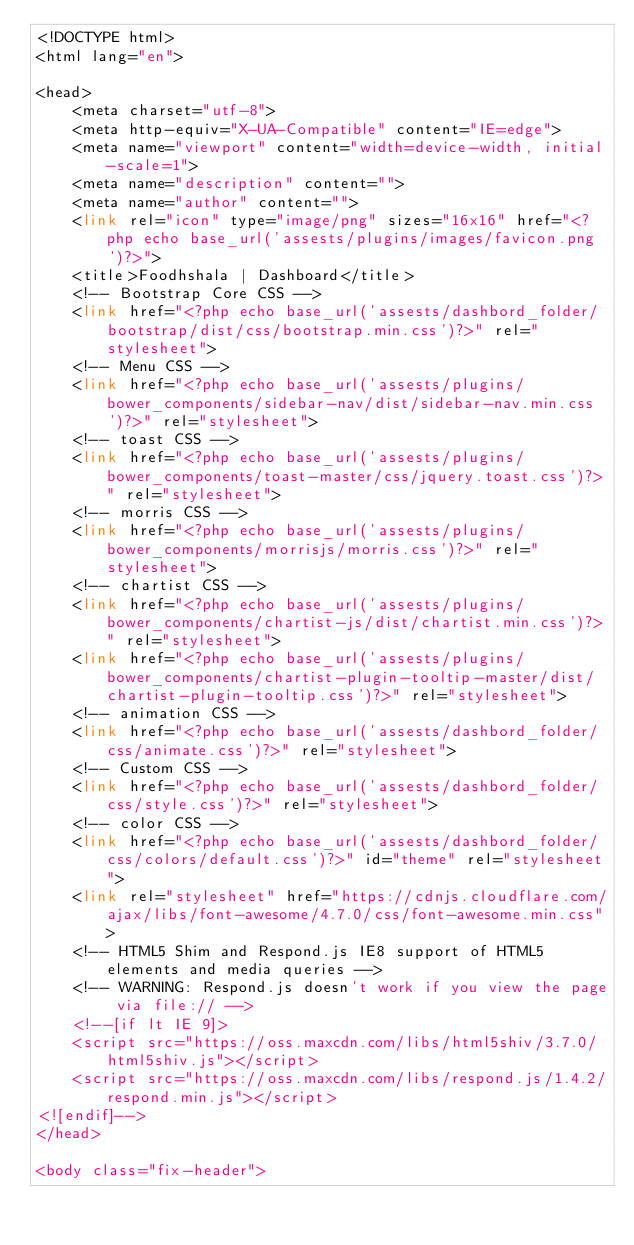Convert code to text. <code><loc_0><loc_0><loc_500><loc_500><_PHP_><!DOCTYPE html>
<html lang="en">

<head>
    <meta charset="utf-8">
    <meta http-equiv="X-UA-Compatible" content="IE=edge">
    <meta name="viewport" content="width=device-width, initial-scale=1">
    <meta name="description" content="">
    <meta name="author" content="">
    <link rel="icon" type="image/png" sizes="16x16" href="<?php echo base_url('assests/plugins/images/favicon.png')?>">
    <title>Foodhshala | Dashboard</title>
    <!-- Bootstrap Core CSS -->
    <link href="<?php echo base_url('assests/dashbord_folder/bootstrap/dist/css/bootstrap.min.css')?>" rel="stylesheet">
    <!-- Menu CSS -->
    <link href="<?php echo base_url('assests/plugins/bower_components/sidebar-nav/dist/sidebar-nav.min.css')?>" rel="stylesheet">
    <!-- toast CSS -->
    <link href="<?php echo base_url('assests/plugins/bower_components/toast-master/css/jquery.toast.css')?>" rel="stylesheet">
    <!-- morris CSS -->
    <link href="<?php echo base_url('assests/plugins/bower_components/morrisjs/morris.css')?>" rel="stylesheet">
    <!-- chartist CSS -->
    <link href="<?php echo base_url('assests/plugins/bower_components/chartist-js/dist/chartist.min.css')?>" rel="stylesheet">
    <link href="<?php echo base_url('assests/plugins/bower_components/chartist-plugin-tooltip-master/dist/chartist-plugin-tooltip.css')?>" rel="stylesheet">
    <!-- animation CSS -->
    <link href="<?php echo base_url('assests/dashbord_folder/css/animate.css')?>" rel="stylesheet">
    <!-- Custom CSS -->
    <link href="<?php echo base_url('assests/dashbord_folder/css/style.css')?>" rel="stylesheet">
    <!-- color CSS -->
    <link href="<?php echo base_url('assests/dashbord_folder/css/colors/default.css')?>" id="theme" rel="stylesheet">
    <link rel="stylesheet" href="https://cdnjs.cloudflare.com/ajax/libs/font-awesome/4.7.0/css/font-awesome.min.css">
    <!-- HTML5 Shim and Respond.js IE8 support of HTML5 elements and media queries -->
    <!-- WARNING: Respond.js doesn't work if you view the page via file:// -->
    <!--[if lt IE 9]>
    <script src="https://oss.maxcdn.com/libs/html5shiv/3.7.0/html5shiv.js"></script>
    <script src="https://oss.maxcdn.com/libs/respond.js/1.4.2/respond.min.js"></script>
<![endif]-->
</head>

<body class="fix-header"></code> 